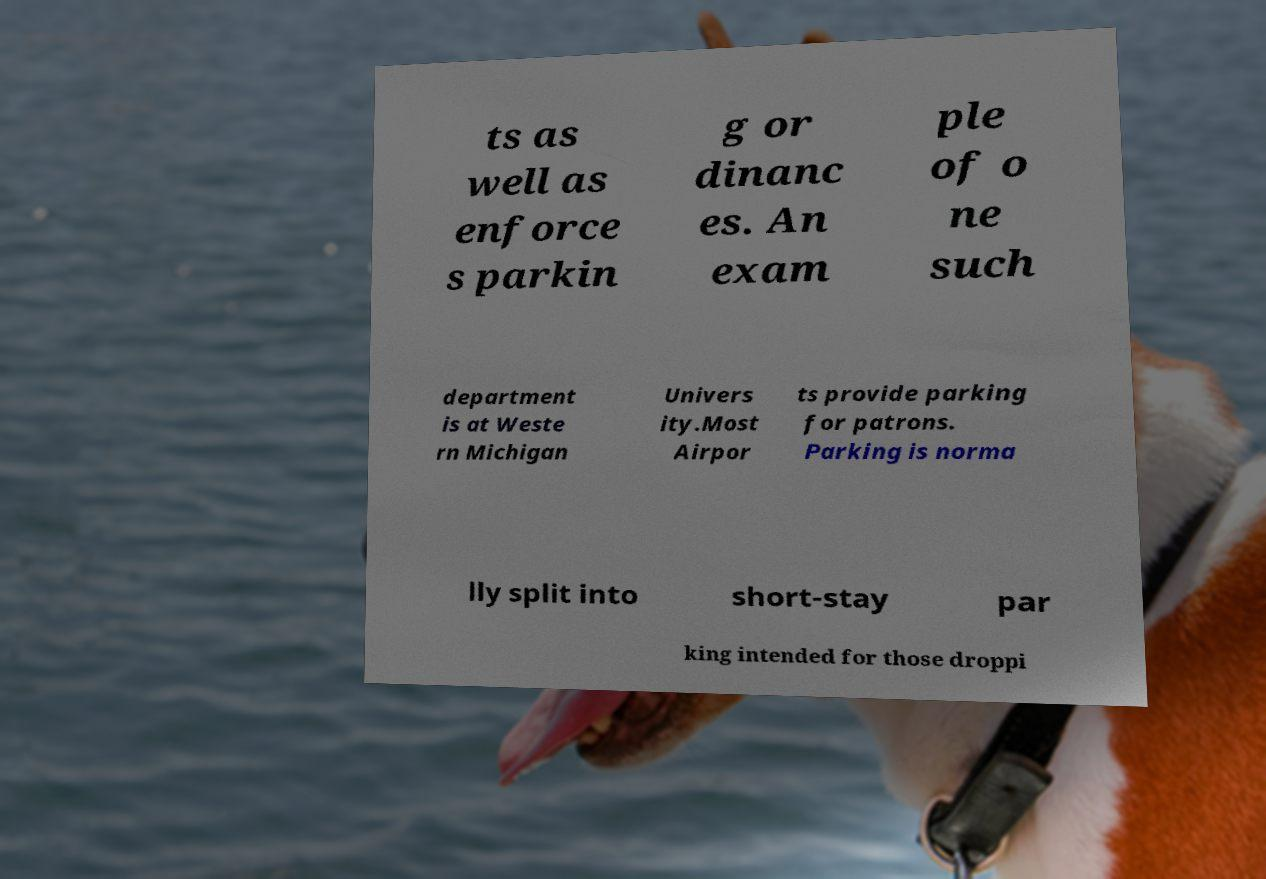Please identify and transcribe the text found in this image. ts as well as enforce s parkin g or dinanc es. An exam ple of o ne such department is at Weste rn Michigan Univers ity.Most Airpor ts provide parking for patrons. Parking is norma lly split into short-stay par king intended for those droppi 